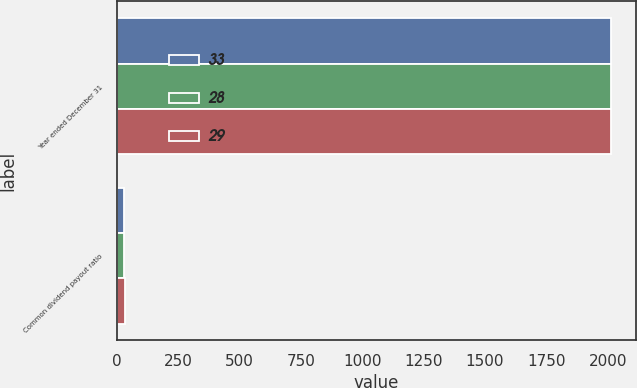<chart> <loc_0><loc_0><loc_500><loc_500><stacked_bar_chart><ecel><fcel>Year ended December 31<fcel>Common dividend payout ratio<nl><fcel>33<fcel>2015<fcel>28<nl><fcel>28<fcel>2014<fcel>29<nl><fcel>29<fcel>2013<fcel>33<nl></chart> 